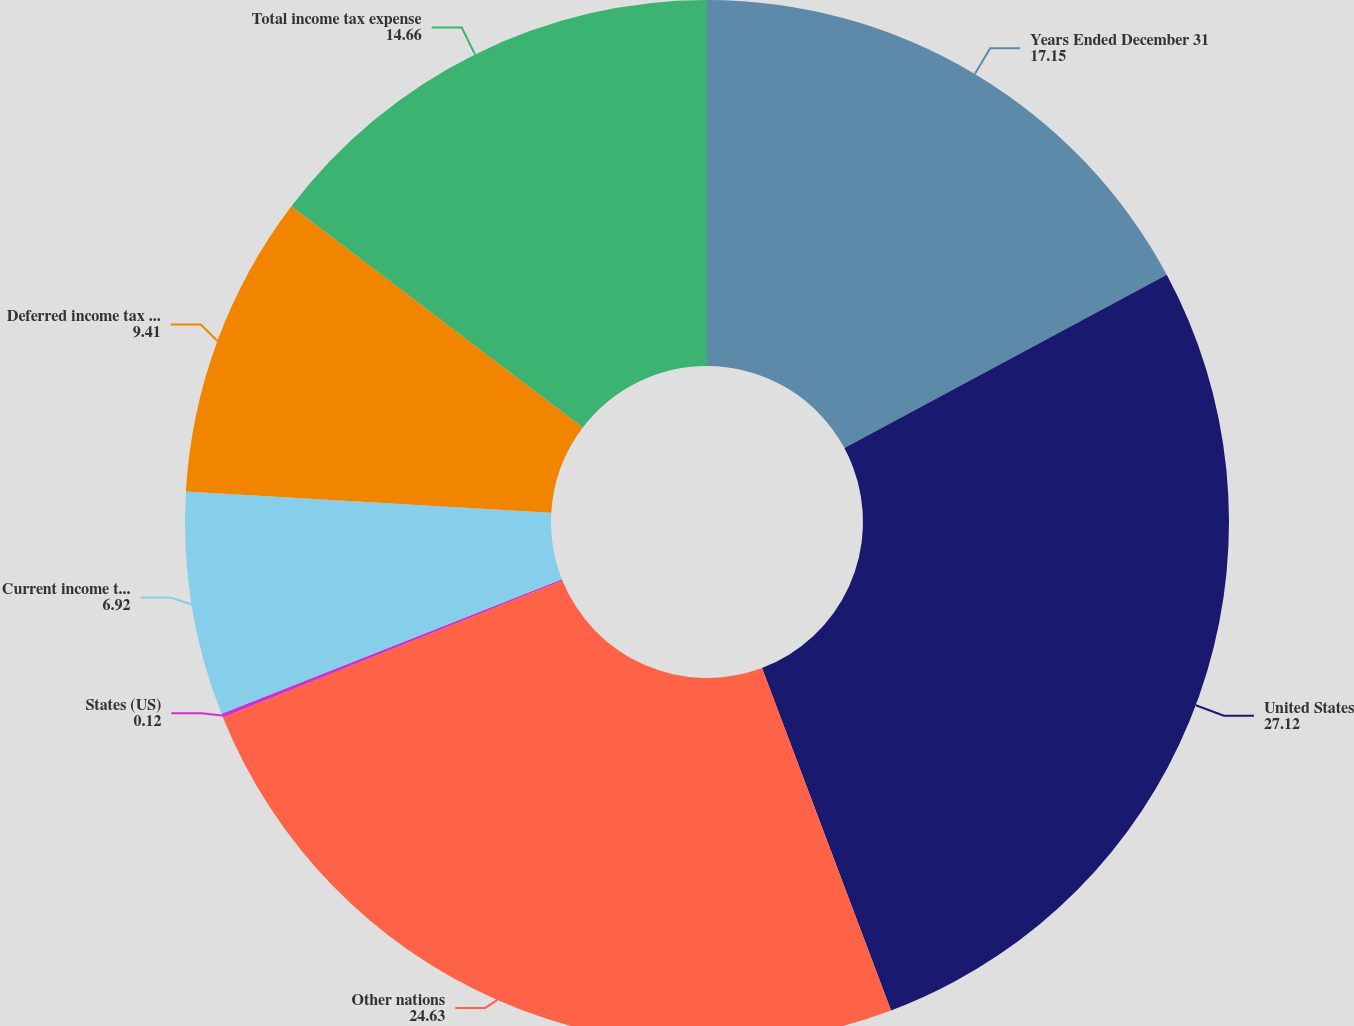<chart> <loc_0><loc_0><loc_500><loc_500><pie_chart><fcel>Years Ended December 31<fcel>United States<fcel>Other nations<fcel>States (US)<fcel>Current income tax expense<fcel>Deferred income tax expense<fcel>Total income tax expense<nl><fcel>17.15%<fcel>27.12%<fcel>24.63%<fcel>0.12%<fcel>6.92%<fcel>9.41%<fcel>14.66%<nl></chart> 